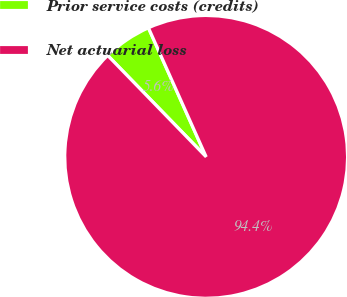Convert chart. <chart><loc_0><loc_0><loc_500><loc_500><pie_chart><fcel>Prior service costs (credits)<fcel>Net actuarial loss<nl><fcel>5.57%<fcel>94.43%<nl></chart> 